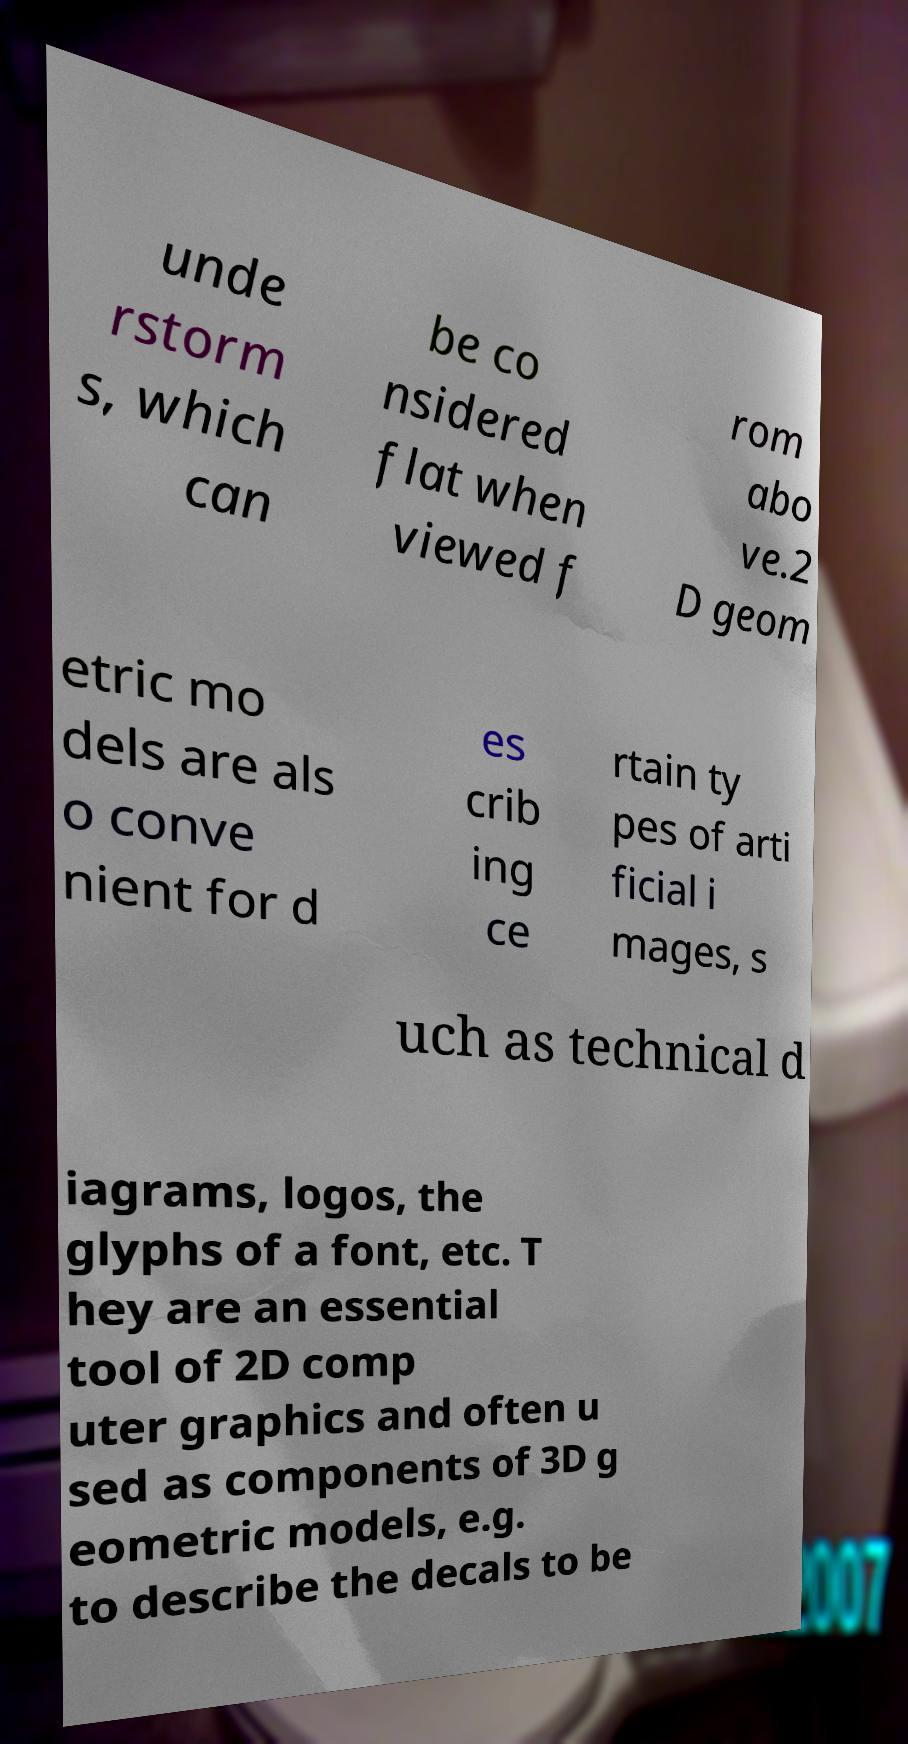There's text embedded in this image that I need extracted. Can you transcribe it verbatim? unde rstorm s, which can be co nsidered flat when viewed f rom abo ve.2 D geom etric mo dels are als o conve nient for d es crib ing ce rtain ty pes of arti ficial i mages, s uch as technical d iagrams, logos, the glyphs of a font, etc. T hey are an essential tool of 2D comp uter graphics and often u sed as components of 3D g eometric models, e.g. to describe the decals to be 